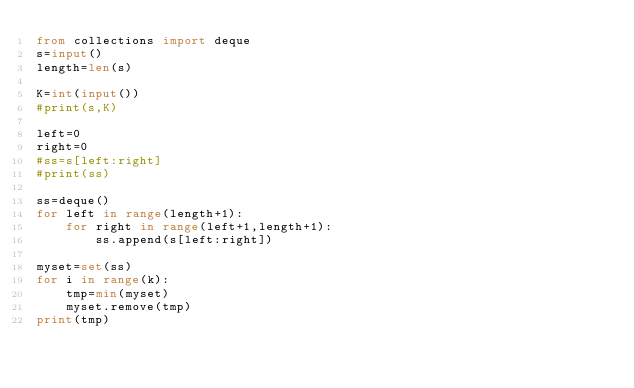Convert code to text. <code><loc_0><loc_0><loc_500><loc_500><_Python_>from collections import deque
s=input()
length=len(s)

K=int(input())
#print(s,K)

left=0
right=0
#ss=s[left:right]
#print(ss)

ss=deque()
for left in range(length+1):
    for right in range(left+1,length+1):
        ss.append(s[left:right])

myset=set(ss)
for i in range(k):
    tmp=min(myset)
    myset.remove(tmp)
print(tmp)

</code> 